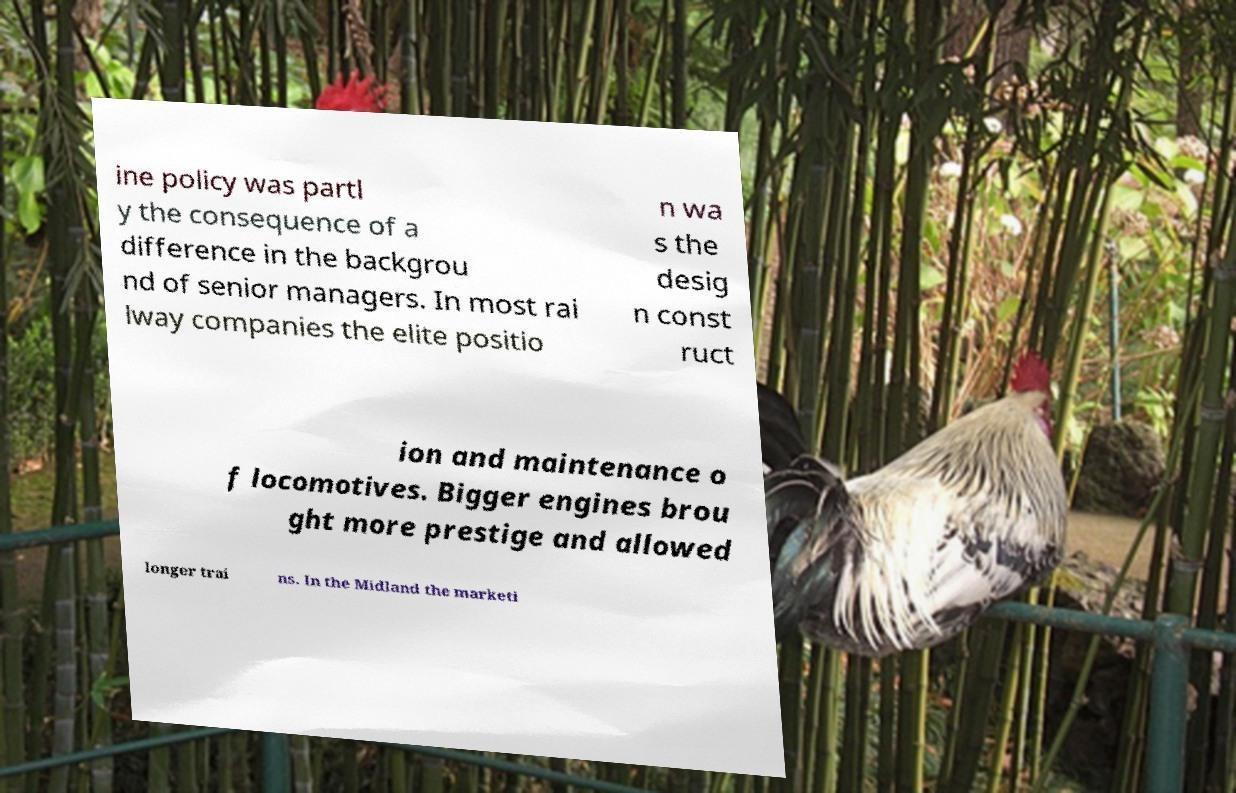Can you accurately transcribe the text from the provided image for me? ine policy was partl y the consequence of a difference in the backgrou nd of senior managers. In most rai lway companies the elite positio n wa s the desig n const ruct ion and maintenance o f locomotives. Bigger engines brou ght more prestige and allowed longer trai ns. In the Midland the marketi 